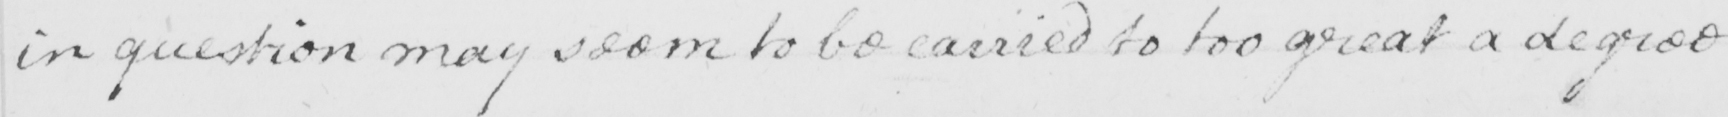What does this handwritten line say? in question may seem to be carried to too great a degree 